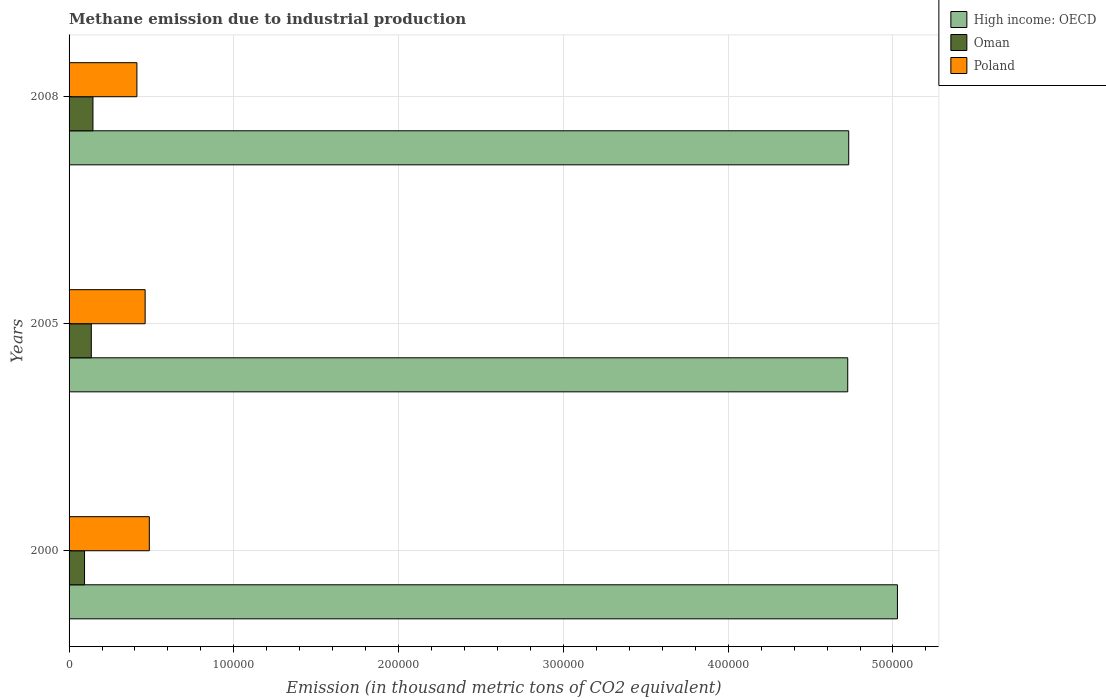How many different coloured bars are there?
Provide a short and direct response. 3. How many groups of bars are there?
Offer a terse response. 3. Are the number of bars per tick equal to the number of legend labels?
Your response must be concise. Yes. How many bars are there on the 1st tick from the bottom?
Your response must be concise. 3. What is the amount of methane emitted in Poland in 2000?
Keep it short and to the point. 4.87e+04. Across all years, what is the maximum amount of methane emitted in Oman?
Offer a terse response. 1.45e+04. Across all years, what is the minimum amount of methane emitted in Oman?
Offer a very short reply. 9388.4. In which year was the amount of methane emitted in Oman maximum?
Give a very brief answer. 2008. What is the total amount of methane emitted in Oman in the graph?
Give a very brief answer. 3.74e+04. What is the difference between the amount of methane emitted in High income: OECD in 2005 and that in 2008?
Provide a short and direct response. -593. What is the difference between the amount of methane emitted in High income: OECD in 2005 and the amount of methane emitted in Oman in 2008?
Keep it short and to the point. 4.58e+05. What is the average amount of methane emitted in Poland per year?
Ensure brevity in your answer.  4.53e+04. In the year 2000, what is the difference between the amount of methane emitted in Oman and amount of methane emitted in High income: OECD?
Make the answer very short. -4.93e+05. What is the ratio of the amount of methane emitted in Oman in 2000 to that in 2008?
Keep it short and to the point. 0.65. What is the difference between the highest and the second highest amount of methane emitted in Poland?
Offer a terse response. 2536.5. What is the difference between the highest and the lowest amount of methane emitted in High income: OECD?
Provide a succinct answer. 3.02e+04. What does the 2nd bar from the bottom in 2005 represents?
Give a very brief answer. Oman. Is it the case that in every year, the sum of the amount of methane emitted in Oman and amount of methane emitted in Poland is greater than the amount of methane emitted in High income: OECD?
Keep it short and to the point. No. How many bars are there?
Keep it short and to the point. 9. How many years are there in the graph?
Offer a very short reply. 3. Does the graph contain grids?
Provide a succinct answer. Yes. How many legend labels are there?
Offer a terse response. 3. How are the legend labels stacked?
Ensure brevity in your answer.  Vertical. What is the title of the graph?
Your response must be concise. Methane emission due to industrial production. Does "Palau" appear as one of the legend labels in the graph?
Give a very brief answer. No. What is the label or title of the X-axis?
Your answer should be very brief. Emission (in thousand metric tons of CO2 equivalent). What is the label or title of the Y-axis?
Your response must be concise. Years. What is the Emission (in thousand metric tons of CO2 equivalent) in High income: OECD in 2000?
Provide a succinct answer. 5.03e+05. What is the Emission (in thousand metric tons of CO2 equivalent) in Oman in 2000?
Offer a terse response. 9388.4. What is the Emission (in thousand metric tons of CO2 equivalent) of Poland in 2000?
Make the answer very short. 4.87e+04. What is the Emission (in thousand metric tons of CO2 equivalent) of High income: OECD in 2005?
Give a very brief answer. 4.73e+05. What is the Emission (in thousand metric tons of CO2 equivalent) in Oman in 2005?
Your answer should be very brief. 1.35e+04. What is the Emission (in thousand metric tons of CO2 equivalent) of Poland in 2005?
Provide a succinct answer. 4.62e+04. What is the Emission (in thousand metric tons of CO2 equivalent) of High income: OECD in 2008?
Your answer should be very brief. 4.73e+05. What is the Emission (in thousand metric tons of CO2 equivalent) in Oman in 2008?
Your answer should be very brief. 1.45e+04. What is the Emission (in thousand metric tons of CO2 equivalent) in Poland in 2008?
Offer a terse response. 4.12e+04. Across all years, what is the maximum Emission (in thousand metric tons of CO2 equivalent) of High income: OECD?
Offer a very short reply. 5.03e+05. Across all years, what is the maximum Emission (in thousand metric tons of CO2 equivalent) of Oman?
Ensure brevity in your answer.  1.45e+04. Across all years, what is the maximum Emission (in thousand metric tons of CO2 equivalent) of Poland?
Ensure brevity in your answer.  4.87e+04. Across all years, what is the minimum Emission (in thousand metric tons of CO2 equivalent) in High income: OECD?
Offer a terse response. 4.73e+05. Across all years, what is the minimum Emission (in thousand metric tons of CO2 equivalent) of Oman?
Keep it short and to the point. 9388.4. Across all years, what is the minimum Emission (in thousand metric tons of CO2 equivalent) of Poland?
Provide a succinct answer. 4.12e+04. What is the total Emission (in thousand metric tons of CO2 equivalent) in High income: OECD in the graph?
Provide a succinct answer. 1.45e+06. What is the total Emission (in thousand metric tons of CO2 equivalent) in Oman in the graph?
Offer a very short reply. 3.74e+04. What is the total Emission (in thousand metric tons of CO2 equivalent) of Poland in the graph?
Provide a succinct answer. 1.36e+05. What is the difference between the Emission (in thousand metric tons of CO2 equivalent) of High income: OECD in 2000 and that in 2005?
Provide a short and direct response. 3.02e+04. What is the difference between the Emission (in thousand metric tons of CO2 equivalent) in Oman in 2000 and that in 2005?
Make the answer very short. -4099. What is the difference between the Emission (in thousand metric tons of CO2 equivalent) in Poland in 2000 and that in 2005?
Offer a terse response. 2536.5. What is the difference between the Emission (in thousand metric tons of CO2 equivalent) of High income: OECD in 2000 and that in 2008?
Your answer should be compact. 2.96e+04. What is the difference between the Emission (in thousand metric tons of CO2 equivalent) of Oman in 2000 and that in 2008?
Provide a short and direct response. -5100.8. What is the difference between the Emission (in thousand metric tons of CO2 equivalent) in Poland in 2000 and that in 2008?
Ensure brevity in your answer.  7532.6. What is the difference between the Emission (in thousand metric tons of CO2 equivalent) of High income: OECD in 2005 and that in 2008?
Ensure brevity in your answer.  -593. What is the difference between the Emission (in thousand metric tons of CO2 equivalent) of Oman in 2005 and that in 2008?
Provide a succinct answer. -1001.8. What is the difference between the Emission (in thousand metric tons of CO2 equivalent) in Poland in 2005 and that in 2008?
Your answer should be compact. 4996.1. What is the difference between the Emission (in thousand metric tons of CO2 equivalent) in High income: OECD in 2000 and the Emission (in thousand metric tons of CO2 equivalent) in Oman in 2005?
Offer a terse response. 4.89e+05. What is the difference between the Emission (in thousand metric tons of CO2 equivalent) of High income: OECD in 2000 and the Emission (in thousand metric tons of CO2 equivalent) of Poland in 2005?
Offer a very short reply. 4.57e+05. What is the difference between the Emission (in thousand metric tons of CO2 equivalent) in Oman in 2000 and the Emission (in thousand metric tons of CO2 equivalent) in Poland in 2005?
Give a very brief answer. -3.68e+04. What is the difference between the Emission (in thousand metric tons of CO2 equivalent) in High income: OECD in 2000 and the Emission (in thousand metric tons of CO2 equivalent) in Oman in 2008?
Make the answer very short. 4.88e+05. What is the difference between the Emission (in thousand metric tons of CO2 equivalent) of High income: OECD in 2000 and the Emission (in thousand metric tons of CO2 equivalent) of Poland in 2008?
Keep it short and to the point. 4.62e+05. What is the difference between the Emission (in thousand metric tons of CO2 equivalent) in Oman in 2000 and the Emission (in thousand metric tons of CO2 equivalent) in Poland in 2008?
Ensure brevity in your answer.  -3.18e+04. What is the difference between the Emission (in thousand metric tons of CO2 equivalent) of High income: OECD in 2005 and the Emission (in thousand metric tons of CO2 equivalent) of Oman in 2008?
Provide a short and direct response. 4.58e+05. What is the difference between the Emission (in thousand metric tons of CO2 equivalent) in High income: OECD in 2005 and the Emission (in thousand metric tons of CO2 equivalent) in Poland in 2008?
Provide a succinct answer. 4.31e+05. What is the difference between the Emission (in thousand metric tons of CO2 equivalent) in Oman in 2005 and the Emission (in thousand metric tons of CO2 equivalent) in Poland in 2008?
Your answer should be very brief. -2.77e+04. What is the average Emission (in thousand metric tons of CO2 equivalent) of High income: OECD per year?
Keep it short and to the point. 4.83e+05. What is the average Emission (in thousand metric tons of CO2 equivalent) of Oman per year?
Make the answer very short. 1.25e+04. What is the average Emission (in thousand metric tons of CO2 equivalent) in Poland per year?
Your response must be concise. 4.53e+04. In the year 2000, what is the difference between the Emission (in thousand metric tons of CO2 equivalent) in High income: OECD and Emission (in thousand metric tons of CO2 equivalent) in Oman?
Your response must be concise. 4.93e+05. In the year 2000, what is the difference between the Emission (in thousand metric tons of CO2 equivalent) in High income: OECD and Emission (in thousand metric tons of CO2 equivalent) in Poland?
Your answer should be compact. 4.54e+05. In the year 2000, what is the difference between the Emission (in thousand metric tons of CO2 equivalent) of Oman and Emission (in thousand metric tons of CO2 equivalent) of Poland?
Give a very brief answer. -3.93e+04. In the year 2005, what is the difference between the Emission (in thousand metric tons of CO2 equivalent) in High income: OECD and Emission (in thousand metric tons of CO2 equivalent) in Oman?
Your answer should be very brief. 4.59e+05. In the year 2005, what is the difference between the Emission (in thousand metric tons of CO2 equivalent) of High income: OECD and Emission (in thousand metric tons of CO2 equivalent) of Poland?
Offer a terse response. 4.26e+05. In the year 2005, what is the difference between the Emission (in thousand metric tons of CO2 equivalent) of Oman and Emission (in thousand metric tons of CO2 equivalent) of Poland?
Ensure brevity in your answer.  -3.27e+04. In the year 2008, what is the difference between the Emission (in thousand metric tons of CO2 equivalent) of High income: OECD and Emission (in thousand metric tons of CO2 equivalent) of Oman?
Offer a very short reply. 4.59e+05. In the year 2008, what is the difference between the Emission (in thousand metric tons of CO2 equivalent) in High income: OECD and Emission (in thousand metric tons of CO2 equivalent) in Poland?
Offer a terse response. 4.32e+05. In the year 2008, what is the difference between the Emission (in thousand metric tons of CO2 equivalent) of Oman and Emission (in thousand metric tons of CO2 equivalent) of Poland?
Keep it short and to the point. -2.67e+04. What is the ratio of the Emission (in thousand metric tons of CO2 equivalent) in High income: OECD in 2000 to that in 2005?
Your answer should be compact. 1.06. What is the ratio of the Emission (in thousand metric tons of CO2 equivalent) in Oman in 2000 to that in 2005?
Your answer should be very brief. 0.7. What is the ratio of the Emission (in thousand metric tons of CO2 equivalent) in Poland in 2000 to that in 2005?
Keep it short and to the point. 1.05. What is the ratio of the Emission (in thousand metric tons of CO2 equivalent) in High income: OECD in 2000 to that in 2008?
Your response must be concise. 1.06. What is the ratio of the Emission (in thousand metric tons of CO2 equivalent) of Oman in 2000 to that in 2008?
Give a very brief answer. 0.65. What is the ratio of the Emission (in thousand metric tons of CO2 equivalent) in Poland in 2000 to that in 2008?
Your answer should be compact. 1.18. What is the ratio of the Emission (in thousand metric tons of CO2 equivalent) of Oman in 2005 to that in 2008?
Make the answer very short. 0.93. What is the ratio of the Emission (in thousand metric tons of CO2 equivalent) of Poland in 2005 to that in 2008?
Keep it short and to the point. 1.12. What is the difference between the highest and the second highest Emission (in thousand metric tons of CO2 equivalent) in High income: OECD?
Offer a terse response. 2.96e+04. What is the difference between the highest and the second highest Emission (in thousand metric tons of CO2 equivalent) in Oman?
Make the answer very short. 1001.8. What is the difference between the highest and the second highest Emission (in thousand metric tons of CO2 equivalent) in Poland?
Offer a terse response. 2536.5. What is the difference between the highest and the lowest Emission (in thousand metric tons of CO2 equivalent) in High income: OECD?
Your response must be concise. 3.02e+04. What is the difference between the highest and the lowest Emission (in thousand metric tons of CO2 equivalent) in Oman?
Offer a very short reply. 5100.8. What is the difference between the highest and the lowest Emission (in thousand metric tons of CO2 equivalent) of Poland?
Provide a short and direct response. 7532.6. 